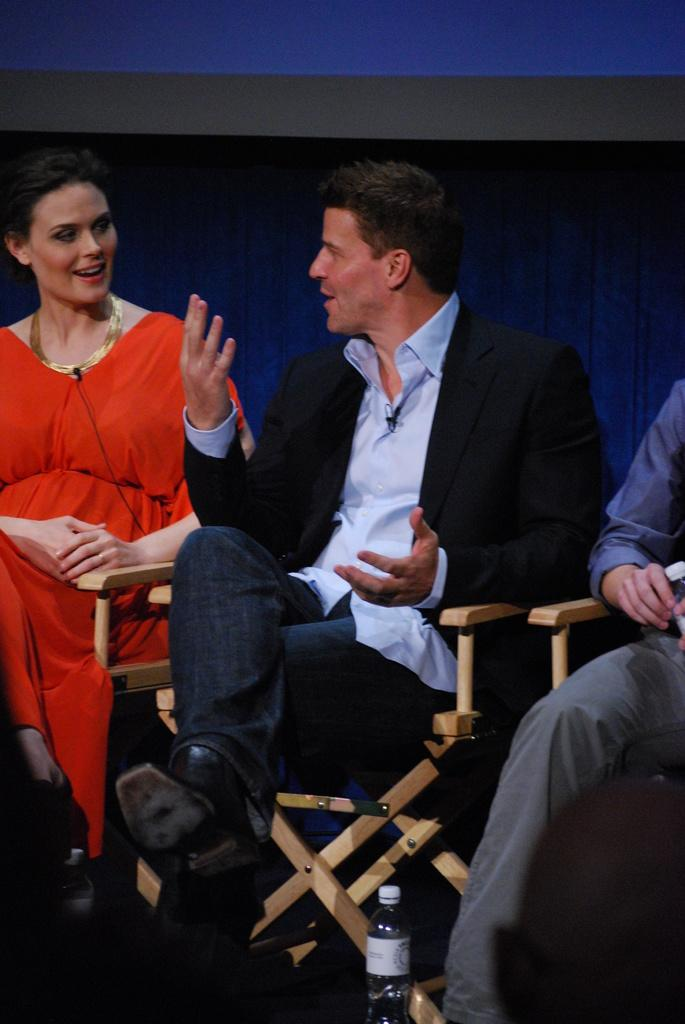Who is present in the image? There are men and a woman in the image. What are the men and woman doing in the image? The men and woman are sitting on chairs. What can be seen in the background of the image? There is a curtain in the background of the image. What is located in the foreground of the image? There is a disposal bottle in the foreground of the image. What type of amusement can be seen in the image? There is no amusement present in the image; it features men and a woman sitting on chairs with a curtain in the background and a disposal bottle in the foreground. 